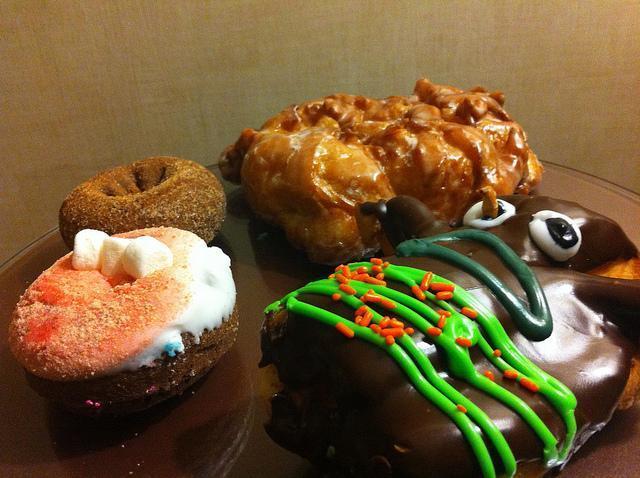How many donuts are in the picture?
Give a very brief answer. 3. 